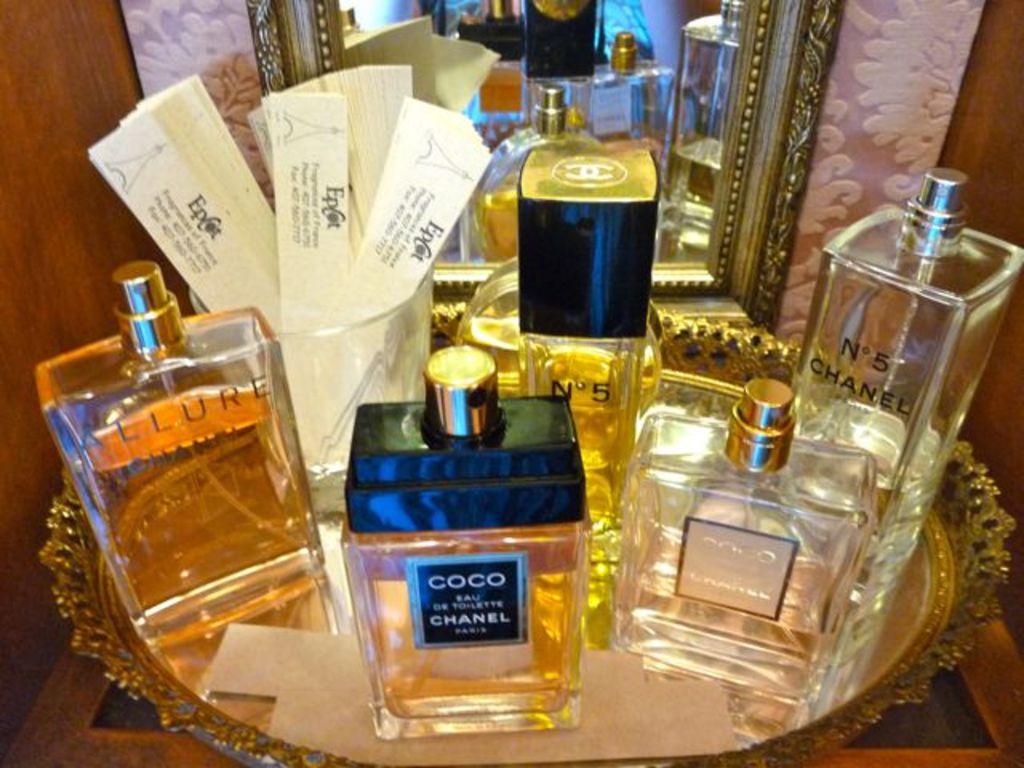What is the brand of the perfume?
Provide a succinct answer. Coco chanel. What is the brand of the leftmost perfume/cologne?
Ensure brevity in your answer.  Allure. 